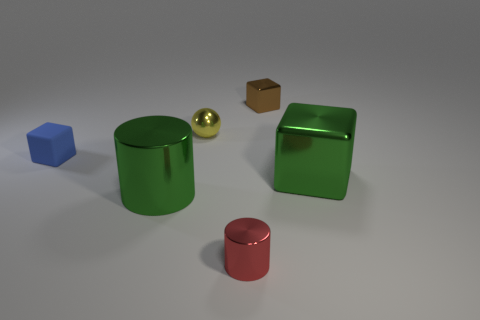Subtract all red cylinders. Subtract all cyan balls. How many cylinders are left? 1 Add 4 small cyan metallic cylinders. How many objects exist? 10 Subtract all cylinders. How many objects are left? 4 Subtract 0 purple spheres. How many objects are left? 6 Subtract all tiny yellow spheres. Subtract all small brown blocks. How many objects are left? 4 Add 1 big green metallic cylinders. How many big green metallic cylinders are left? 2 Add 1 tiny shiny things. How many tiny shiny things exist? 4 